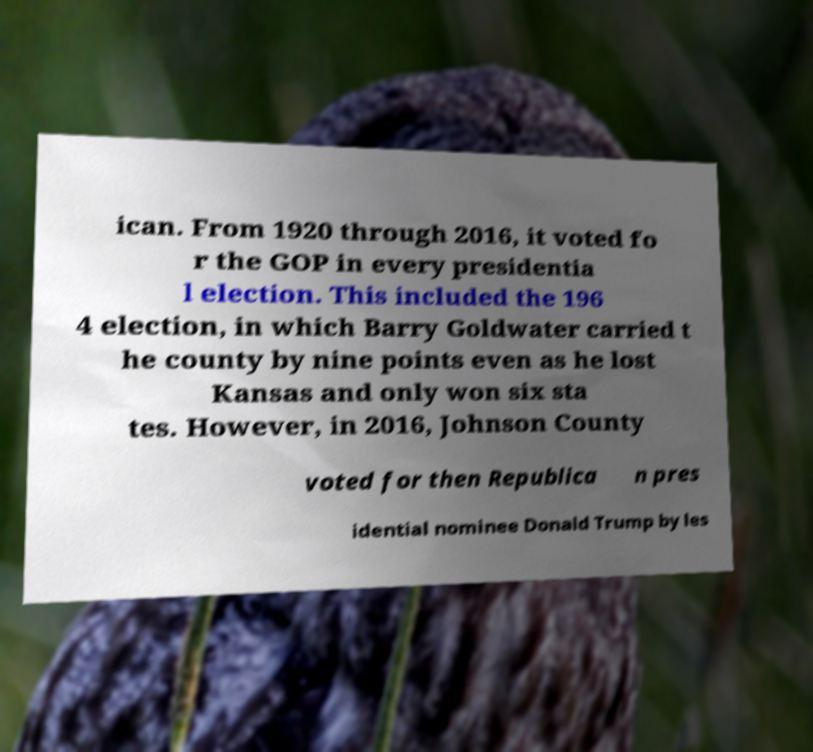I need the written content from this picture converted into text. Can you do that? ican. From 1920 through 2016, it voted fo r the GOP in every presidentia l election. This included the 196 4 election, in which Barry Goldwater carried t he county by nine points even as he lost Kansas and only won six sta tes. However, in 2016, Johnson County voted for then Republica n pres idential nominee Donald Trump by les 